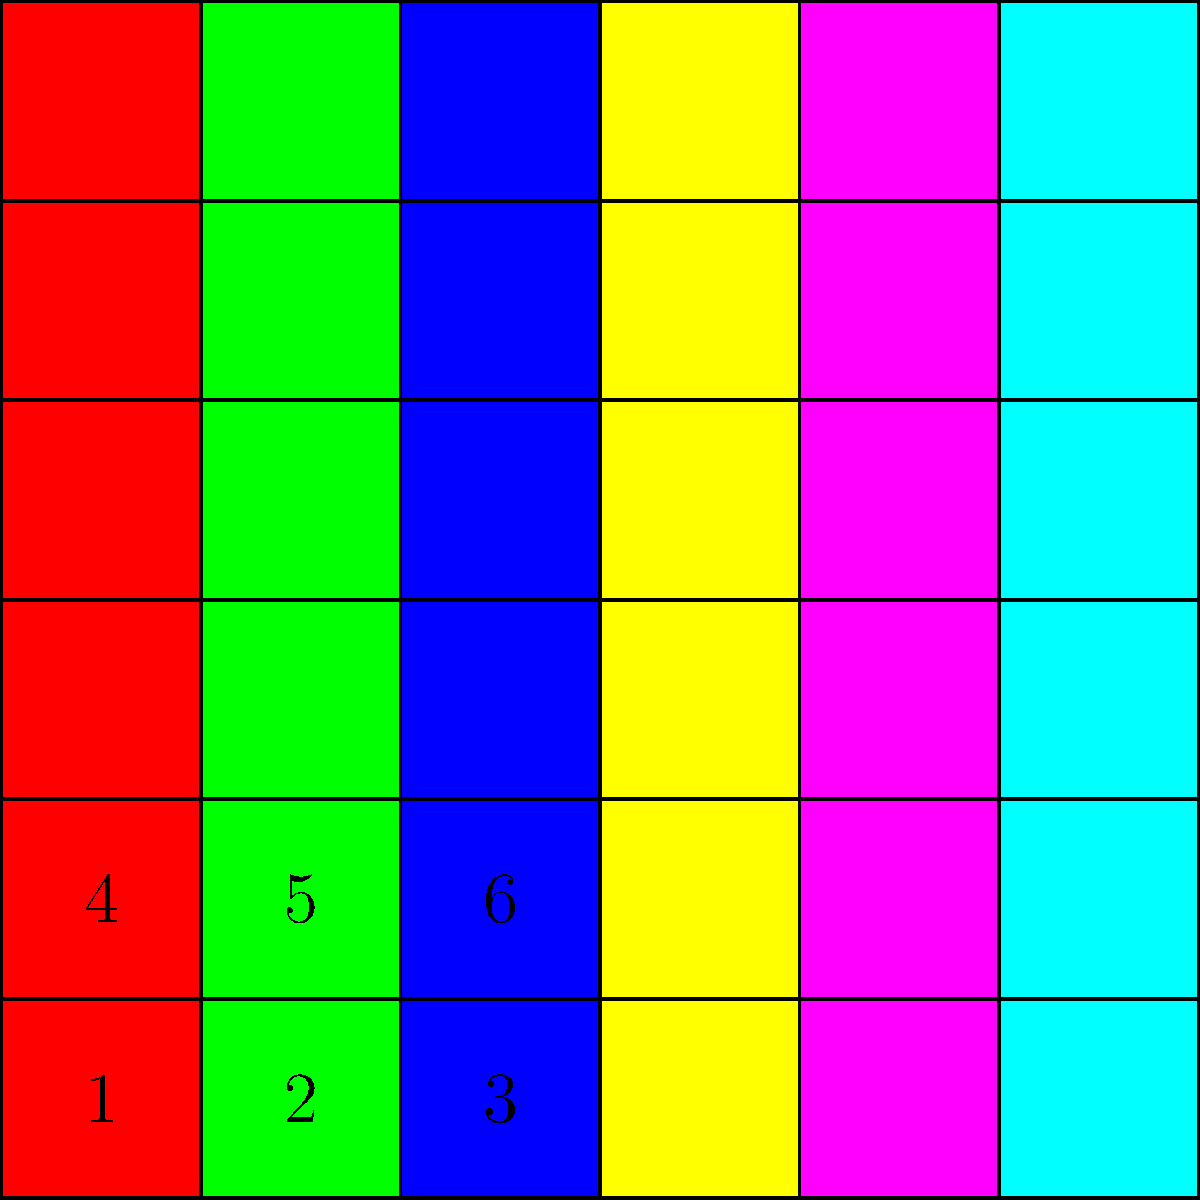In your abstract watercolor landscape, you want to create a vibrant contrast using complementary colors. Based on the color grid shown, which number represents the complementary color to the hue in position 1? To identify the complementary color, we need to follow these steps:

1. Identify the color in position 1: It's red.

2. Recall the color wheel: Complementary colors are directly opposite each other on the color wheel.

3. The complementary color to red is green.

4. Examine the grid to find green:
   - Position 1: Red
   - Position 2: Green
   - Position 3: Blue
   - Position 4: Yellow
   - Position 5: Magenta
   - Position 6: Cyan

5. We can see that green is in position 2.

Therefore, the complementary color to the hue in position 1 is represented by number 2.
Answer: 2 